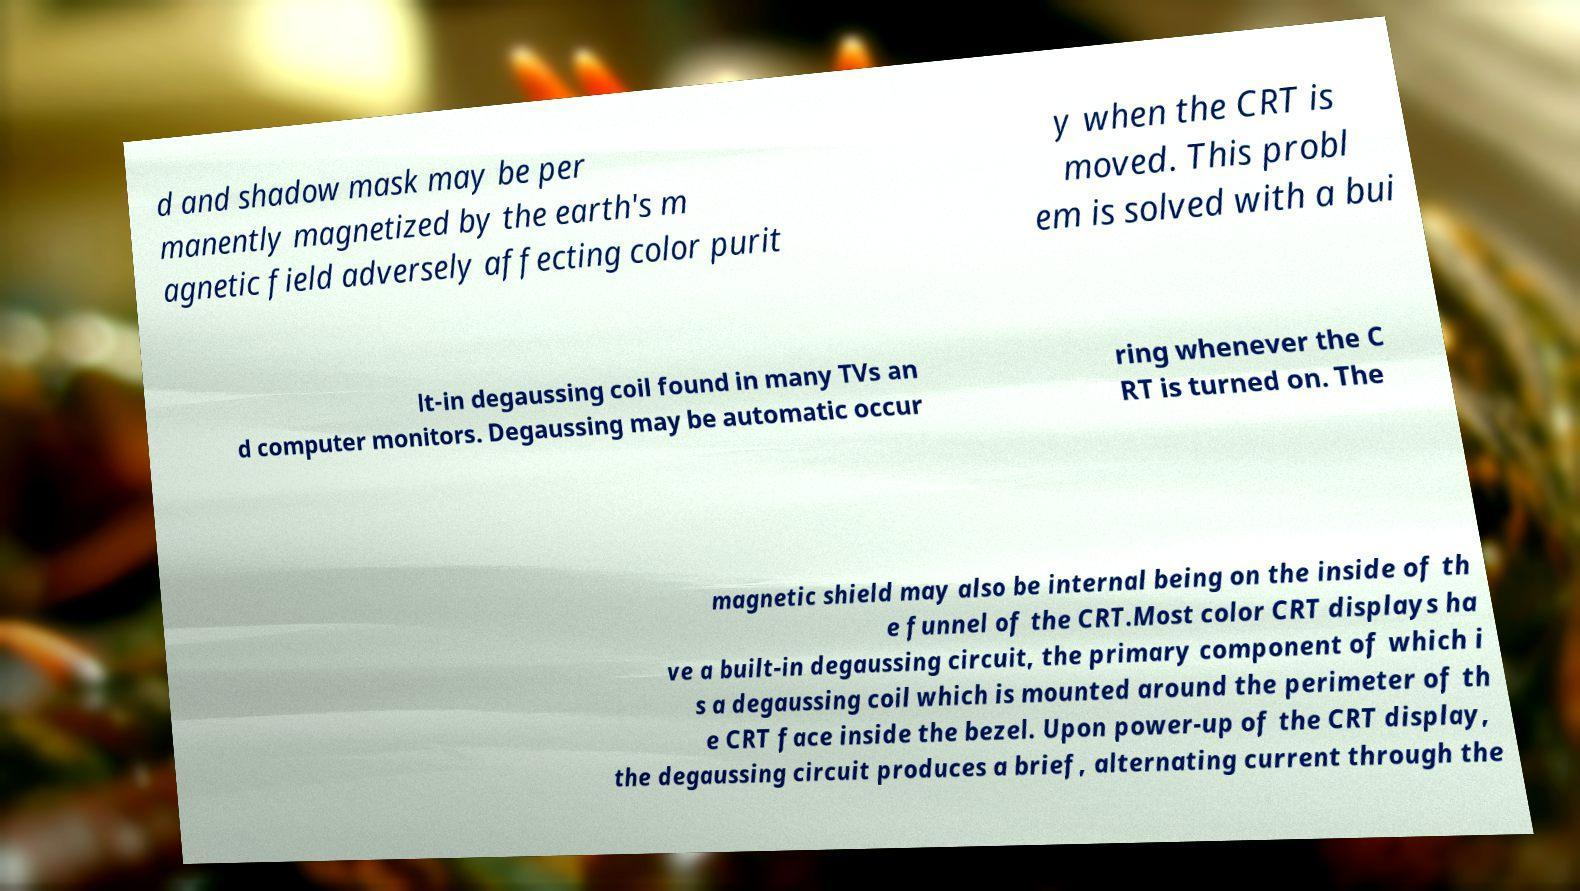Can you read and provide the text displayed in the image?This photo seems to have some interesting text. Can you extract and type it out for me? d and shadow mask may be per manently magnetized by the earth's m agnetic field adversely affecting color purit y when the CRT is moved. This probl em is solved with a bui lt-in degaussing coil found in many TVs an d computer monitors. Degaussing may be automatic occur ring whenever the C RT is turned on. The magnetic shield may also be internal being on the inside of th e funnel of the CRT.Most color CRT displays ha ve a built-in degaussing circuit, the primary component of which i s a degaussing coil which is mounted around the perimeter of th e CRT face inside the bezel. Upon power-up of the CRT display, the degaussing circuit produces a brief, alternating current through the 